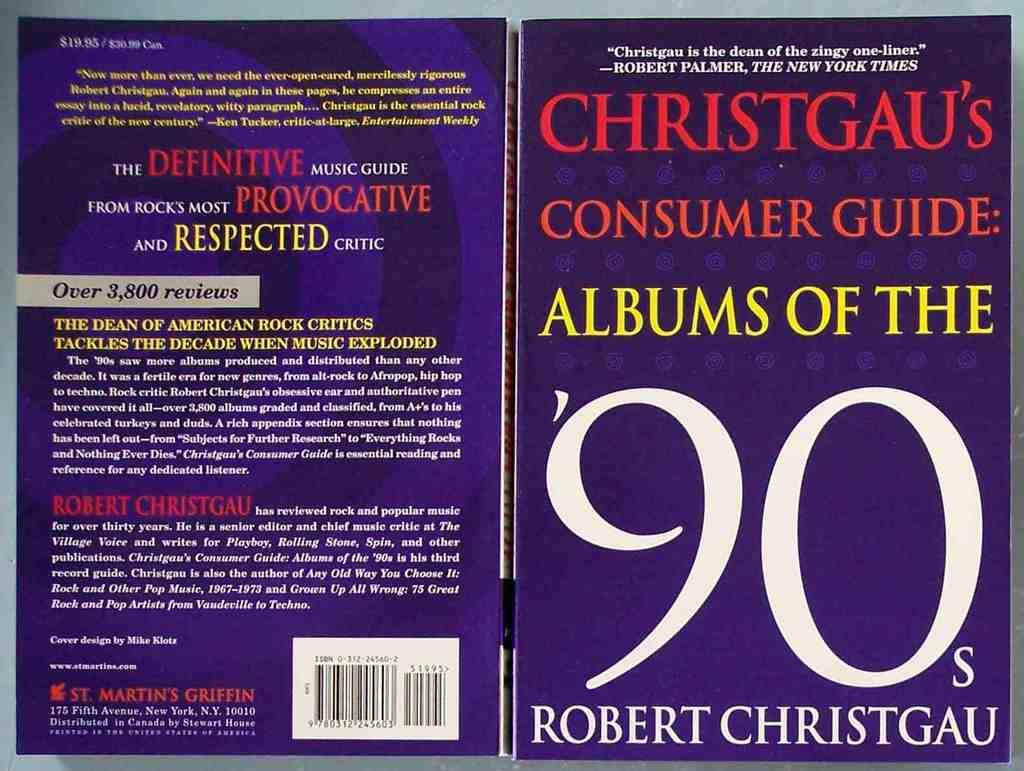<image>
Share a concise interpretation of the image provided. Christgau's consumer guide Albums of the 90s by Robert ChristGau. 